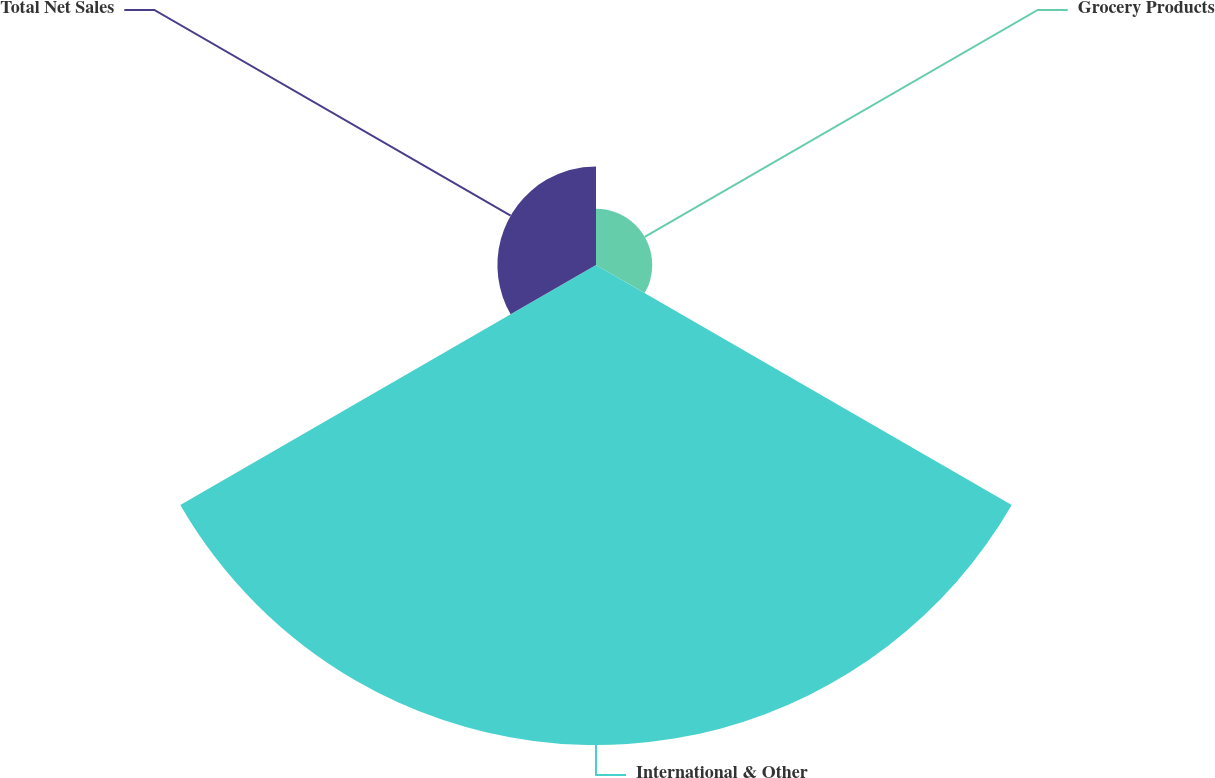<chart> <loc_0><loc_0><loc_500><loc_500><pie_chart><fcel>Grocery Products<fcel>International & Other<fcel>Total Net Sales<nl><fcel>8.86%<fcel>75.61%<fcel>15.53%<nl></chart> 